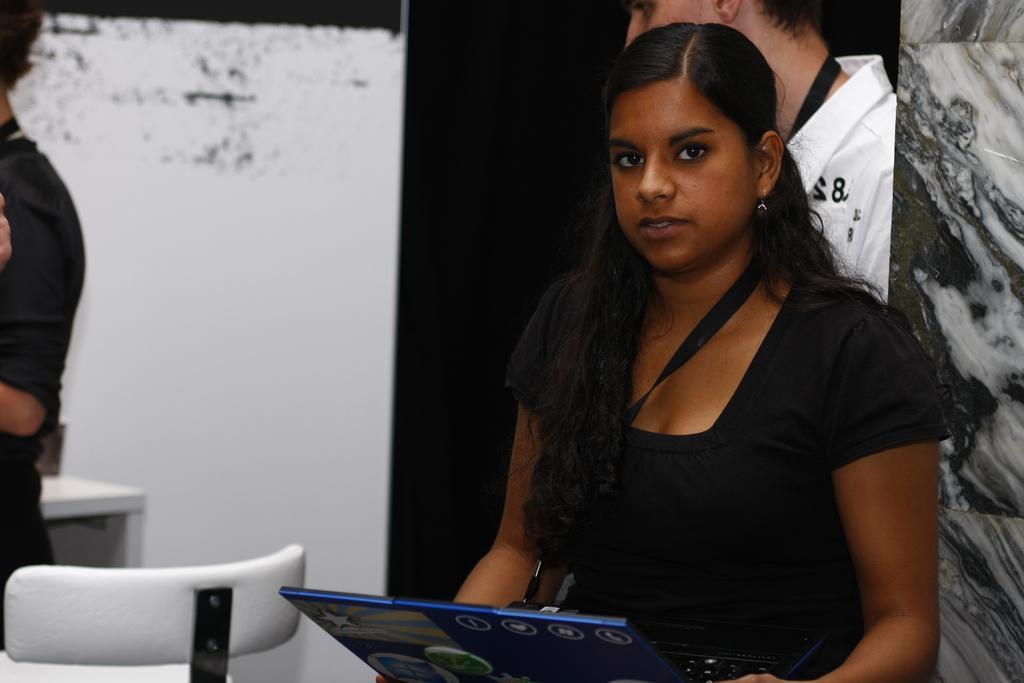Describe this image in one or two sentences. There is a girl on the right side of the image and there is a laptop on her laps. There is a boy behind her, it seems like there is a pillar on the right side and there is a chair at the bottom side of the image. There is a person and a table in the background area. 